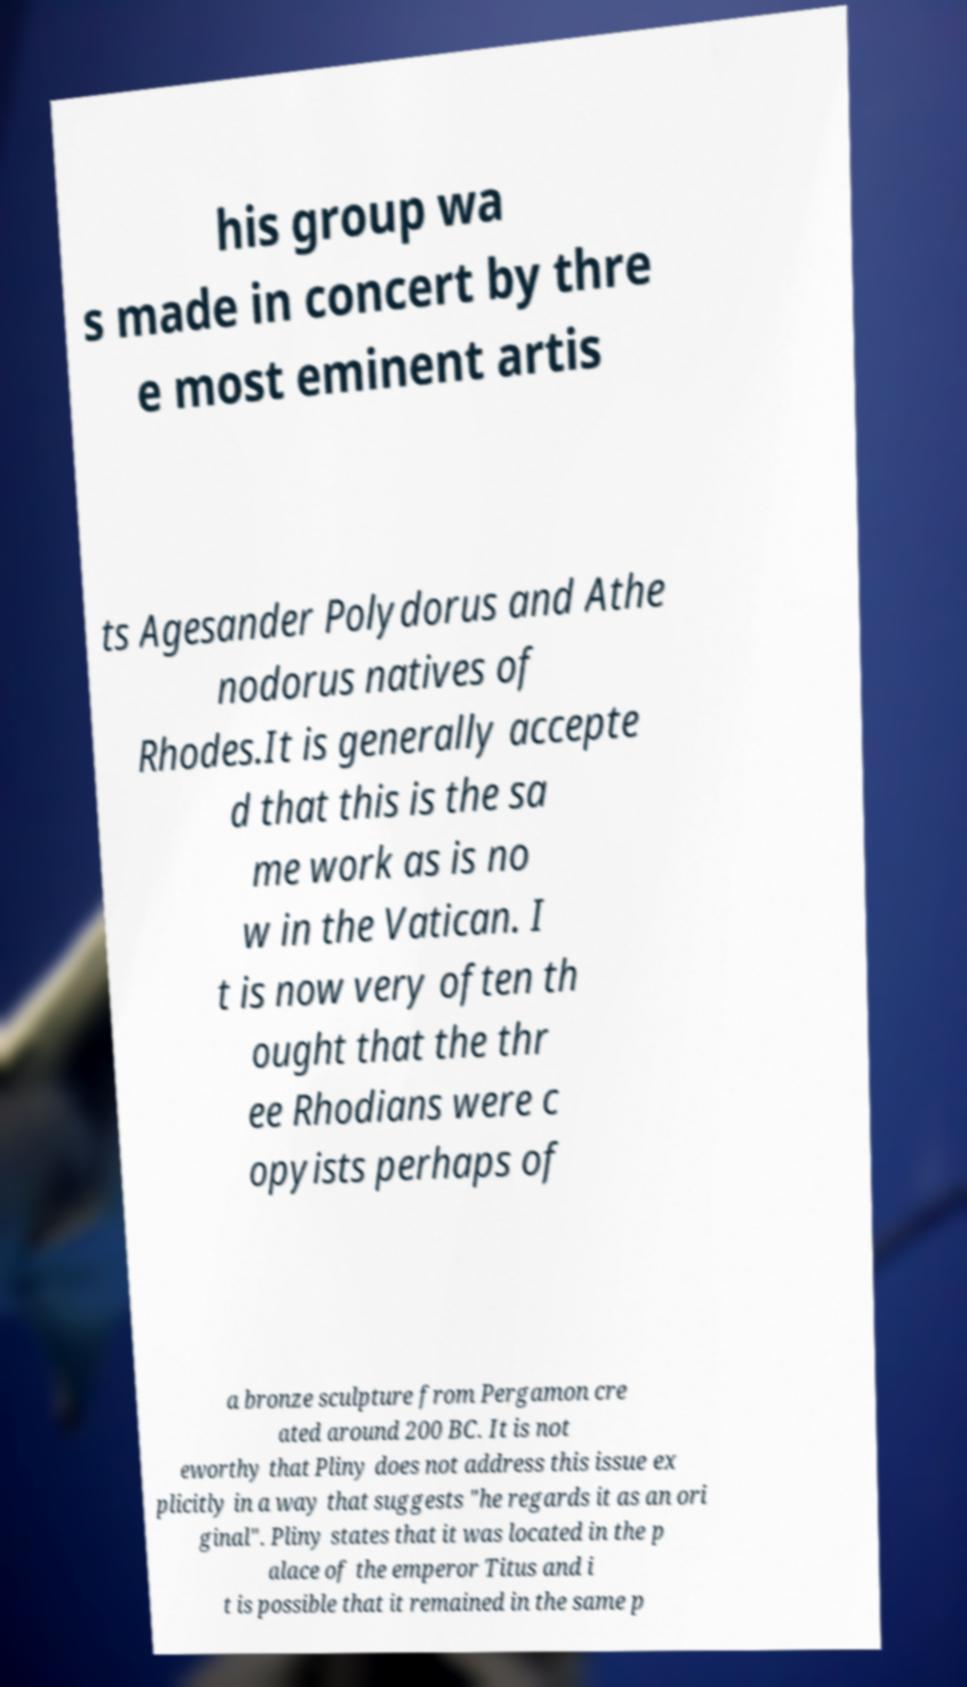Please read and relay the text visible in this image. What does it say? his group wa s made in concert by thre e most eminent artis ts Agesander Polydorus and Athe nodorus natives of Rhodes.It is generally accepte d that this is the sa me work as is no w in the Vatican. I t is now very often th ought that the thr ee Rhodians were c opyists perhaps of a bronze sculpture from Pergamon cre ated around 200 BC. It is not eworthy that Pliny does not address this issue ex plicitly in a way that suggests "he regards it as an ori ginal". Pliny states that it was located in the p alace of the emperor Titus and i t is possible that it remained in the same p 